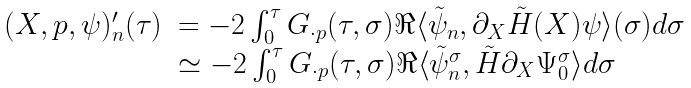Convert formula to latex. <formula><loc_0><loc_0><loc_500><loc_500>\begin{array} { r l } ( X , p , \psi ) ^ { \prime } _ { n } ( \tau ) & = - 2 \int _ { 0 } ^ { \tau } G _ { \cdot p } ( \tau , \sigma ) \Re \langle \tilde { \psi } _ { n } , \partial _ { X } \tilde { H } ( X ) \psi \rangle ( \sigma ) d \sigma \\ & \simeq - 2 \int _ { 0 } ^ { \tau } G _ { \cdot p } ( \tau , \sigma ) \Re \langle \tilde { \psi } _ { n } ^ { \sigma } , \tilde { H } \partial _ { X } \Psi _ { 0 } ^ { \sigma } \rangle d \sigma \end{array}</formula> 